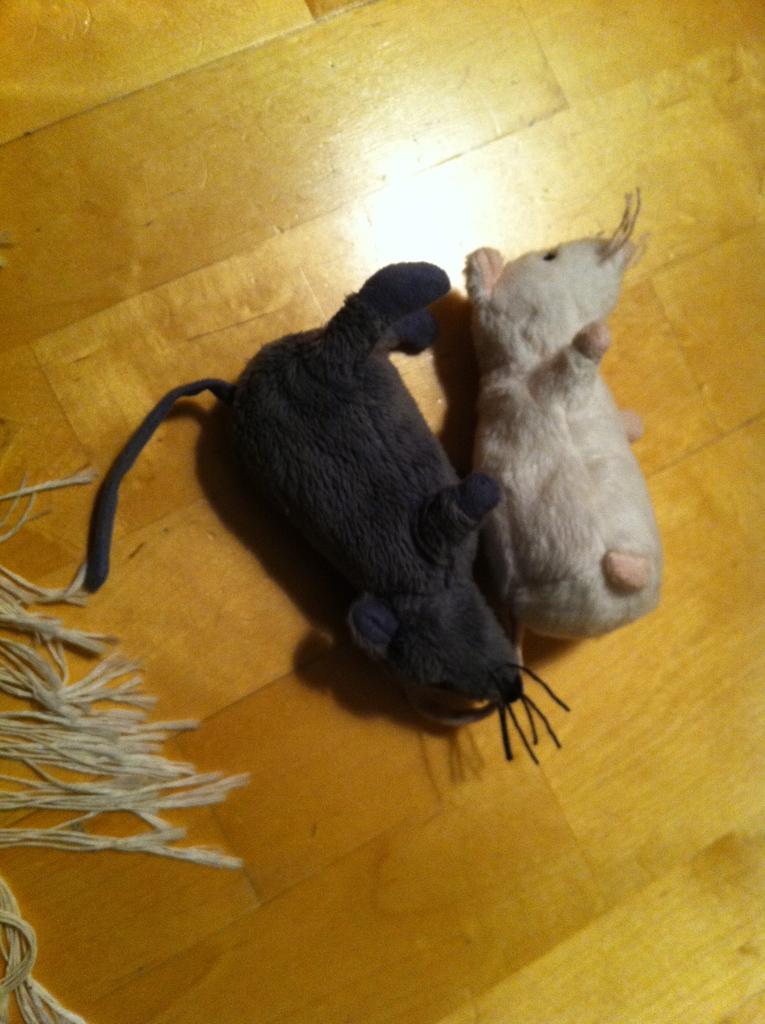Could you give a brief overview of what you see in this image? In this picture we can see there are black and white toys on the wooden floor. On the left side of the toys, it looks like a rag. 